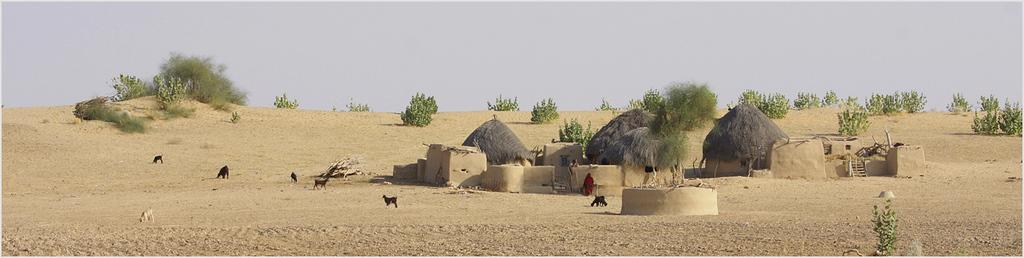What type of terrain is visible in the image? There is ground visible in the image. What type of structures can be seen in the image? There are huts in the image. What type of vegetation is present in the image? Plants and trees are visible in the image. What type of living organisms are present in the image? Animals and a person are present in the image. What is visible in the background of the image? The sky is visible in the background of the image. What type of owl can be seen in the image? There is no owl present in the image. What type of meal is being prepared in the image? There is no meal preparation visible in the image. 